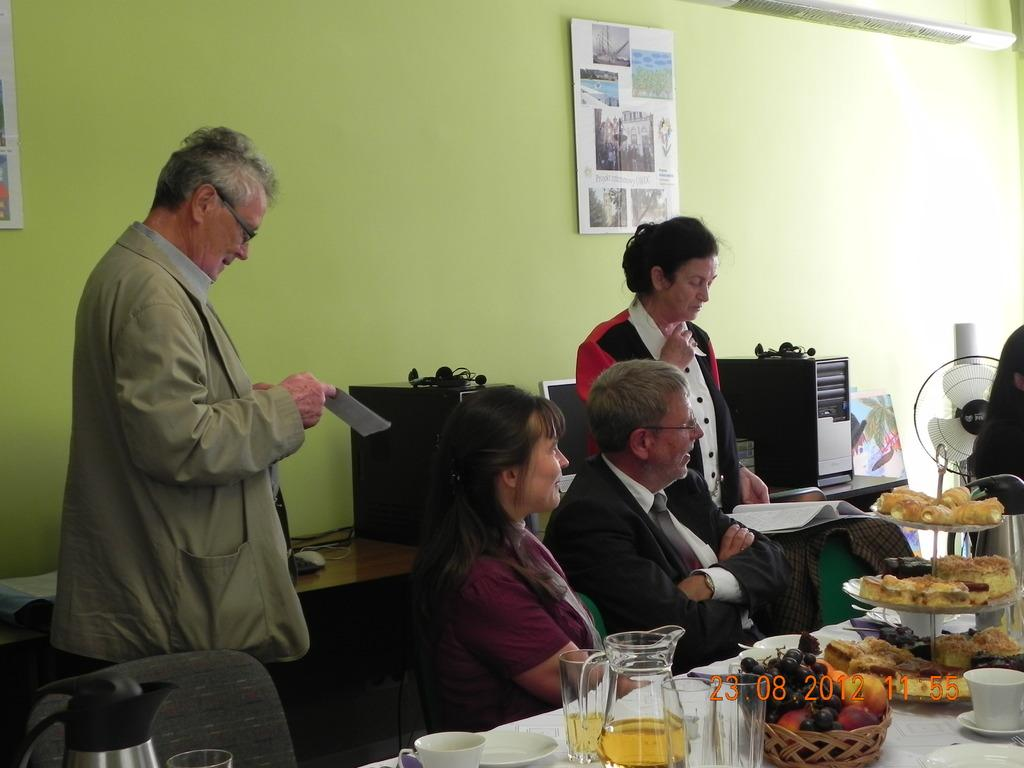How many people are sitting on a chair in the image? There are two people sitting on a chair in the image. What are the two men in front of the table doing? The two men are standing in front of the table. What can be seen on the table? There are glasses, a cup, and other objects on the table. How does the acoustics of the room affect the conversation between the two men in the image? There is no information about the acoustics of the room in the image, so it cannot be determined how it affects the conversation between the two men. 